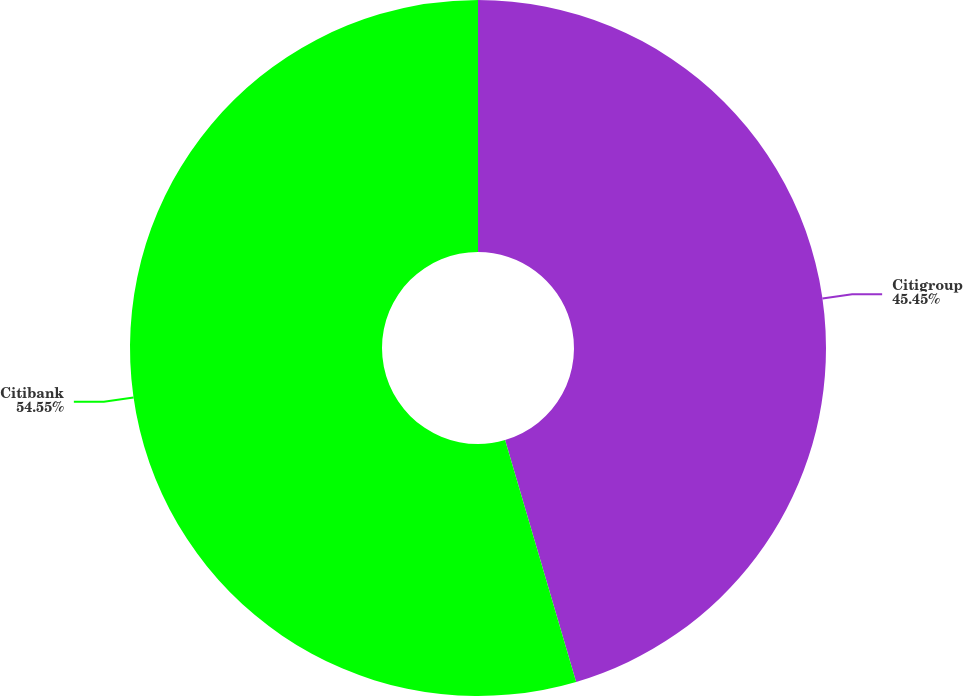Convert chart to OTSL. <chart><loc_0><loc_0><loc_500><loc_500><pie_chart><fcel>Citigroup<fcel>Citibank<nl><fcel>45.45%<fcel>54.55%<nl></chart> 